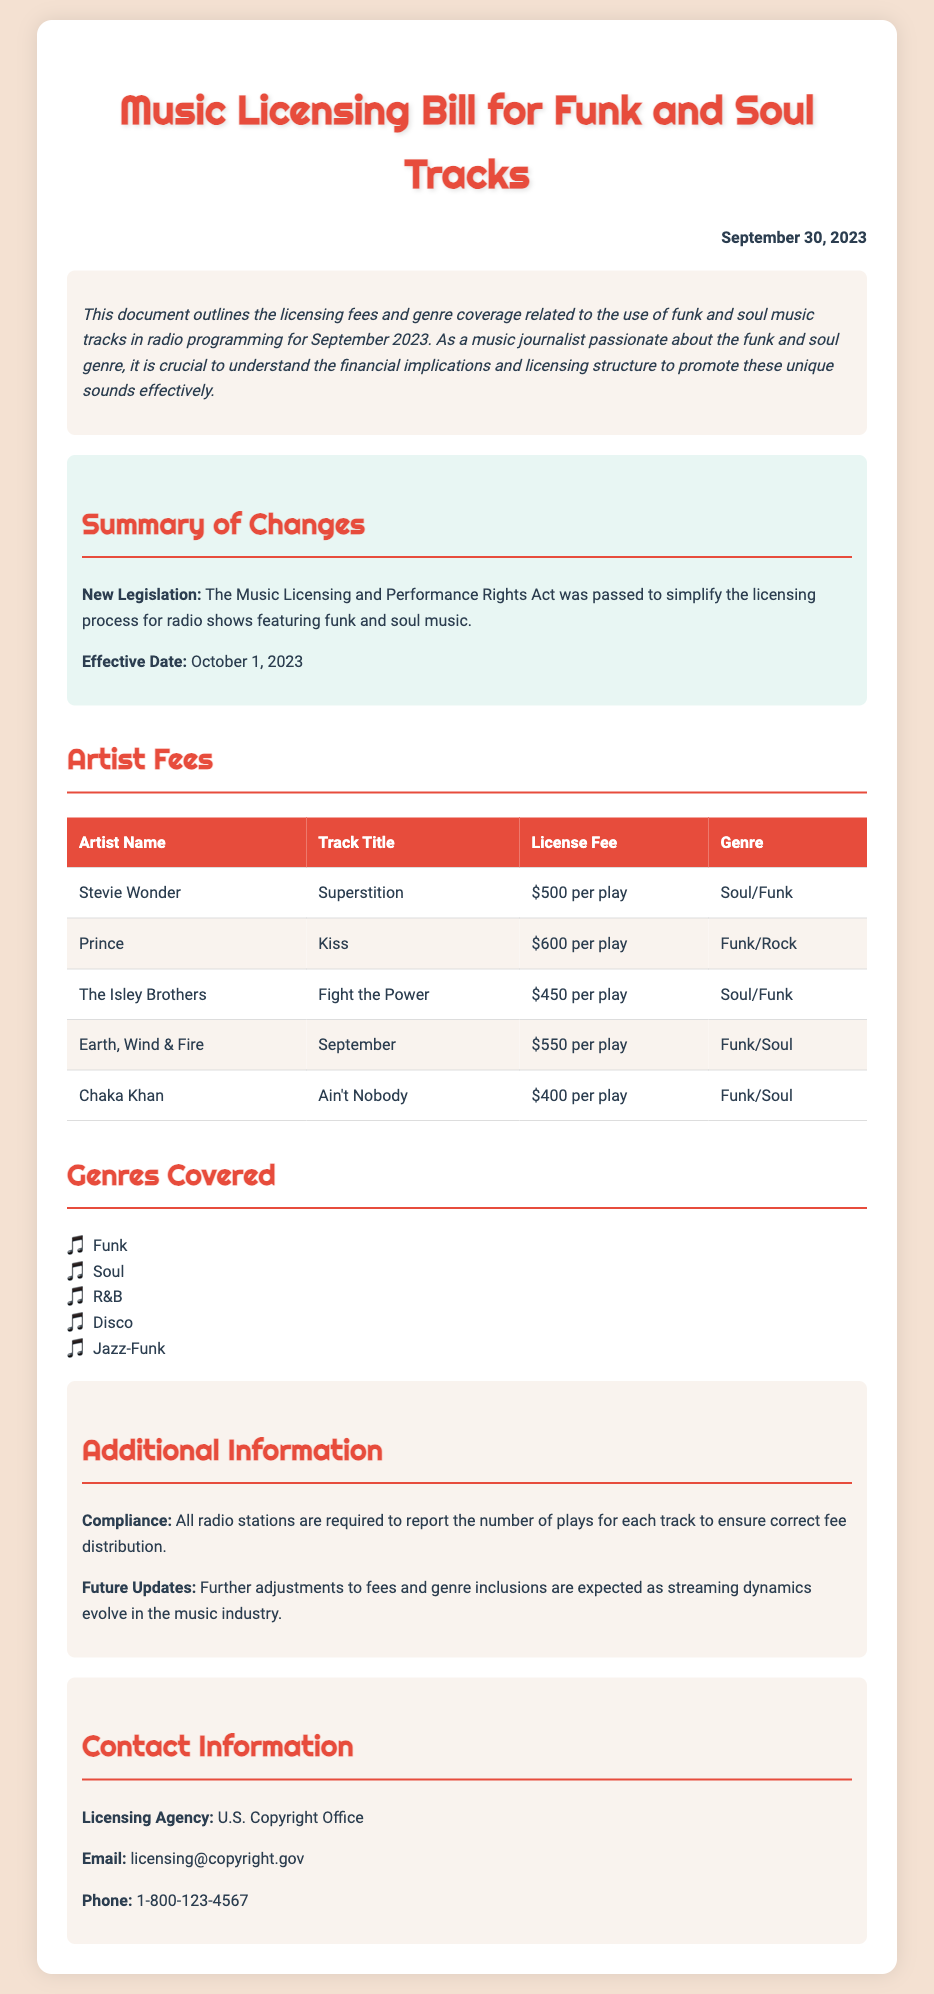what is the effective date of the new legislation? The effective date for the new legislation is mentioned in the summary section, which states it is October 1, 2023.
Answer: October 1, 2023 how much is the license fee for "Superstition"? The document lists the license fee for "Superstition" by Stevie Wonder as $500 per play in the Artist Fees section.
Answer: $500 per play which artist has the highest license fee? By reviewing the Artist Fees table, it is observed that Prince has the highest license fee for "Kiss," which is $600 per play.
Answer: $600 per play what genre does "Ain't Nobody" belong to? The genre for "Ain't Nobody" by Chaka Khan is labeled in the Artist Fees section as Funk/Soul.
Answer: Funk/Soul how many genres are covered in the document? The document lists five different genres covered. This is seen in the Genres Covered section.
Answer: Five what is the email address of the licensing agency? The contact information section specifies the email address as licensing@copyright.gov.
Answer: licensing@copyright.gov what is the license fee for "September"? The fee for "September" by Earth, Wind & Fire is provided in the Artist Fees table, which states it is $550 per play.
Answer: $550 per play what is the title of the bill that was passed? The document mentions the title of the bill as the Music Licensing and Performance Rights Act in the summary section.
Answer: Music Licensing and Performance Rights Act 